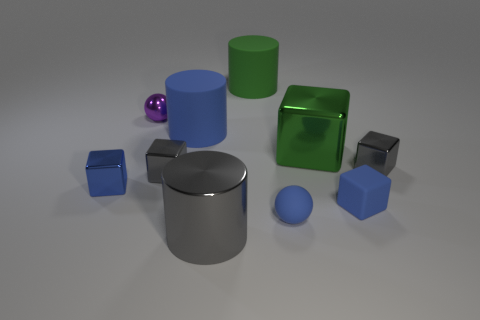Does the ball behind the small matte ball have the same material as the large gray object? The ball behind the small matte ball appears to have a glossy surface, which is consistent with the large grey object that exhibits a reflective, smooth texture. Therefore, based on the visible reflective properties, we can infer that they may be made of similar materials with glossy finishes. 